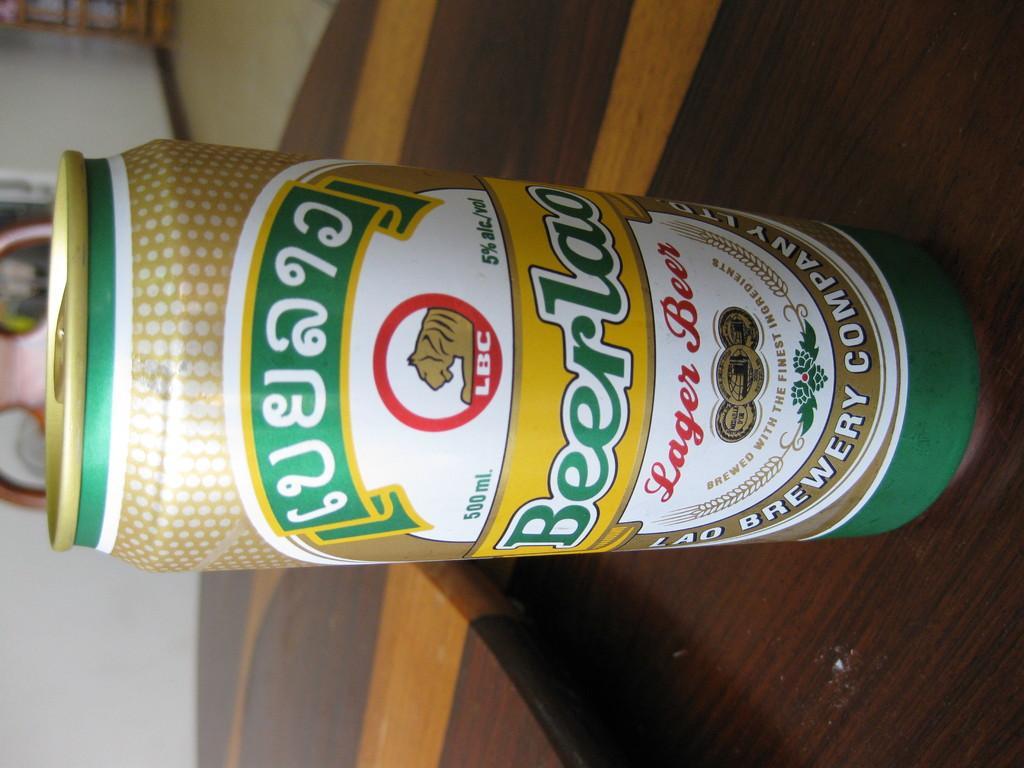In one or two sentences, can you explain what this image depicts? In the picture I can see green color tin on which I can see a label, is placed on the wooden surface. The background of the image is slightly blurred, where I can see a logo or poster on the wall and I can see a few more objects. 